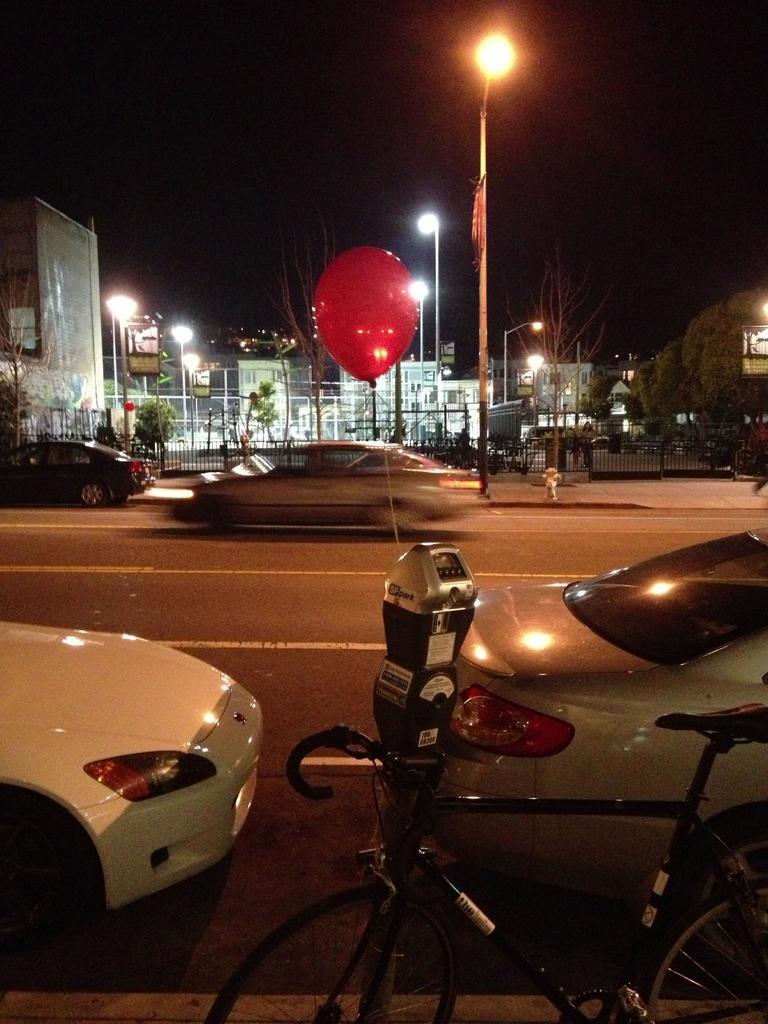Can you describe this image briefly? In this picture we can see a bicycle is a parked on the path and behind the bicycle there is a parking meter and some vehicles parked on the road. Behind the vehicles there's a fire hydrant, poles with lights, trees, buildings, gate and a sky. 